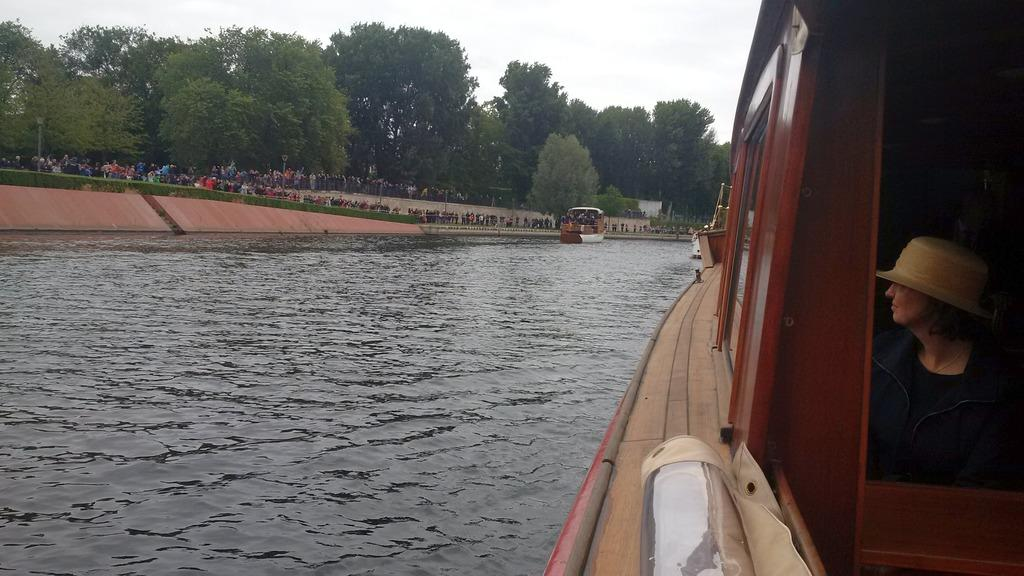What is the main subject of the image? There is a person in a boat on the water. Can you describe the background of the image? In the background, there is a group of persons, grass, poles, iron rods, another boat on the water, trees, and the sky. How many boats are visible in the image? There are two boats visible in the image, one with the person and another in the background. What type of structures can be seen in the background? Poles and iron rods are visible in the background. How many snakes are slithering on the person's boat in the image? There are no snakes present in the image; the person is in a boat on the water with no snakes visible. 